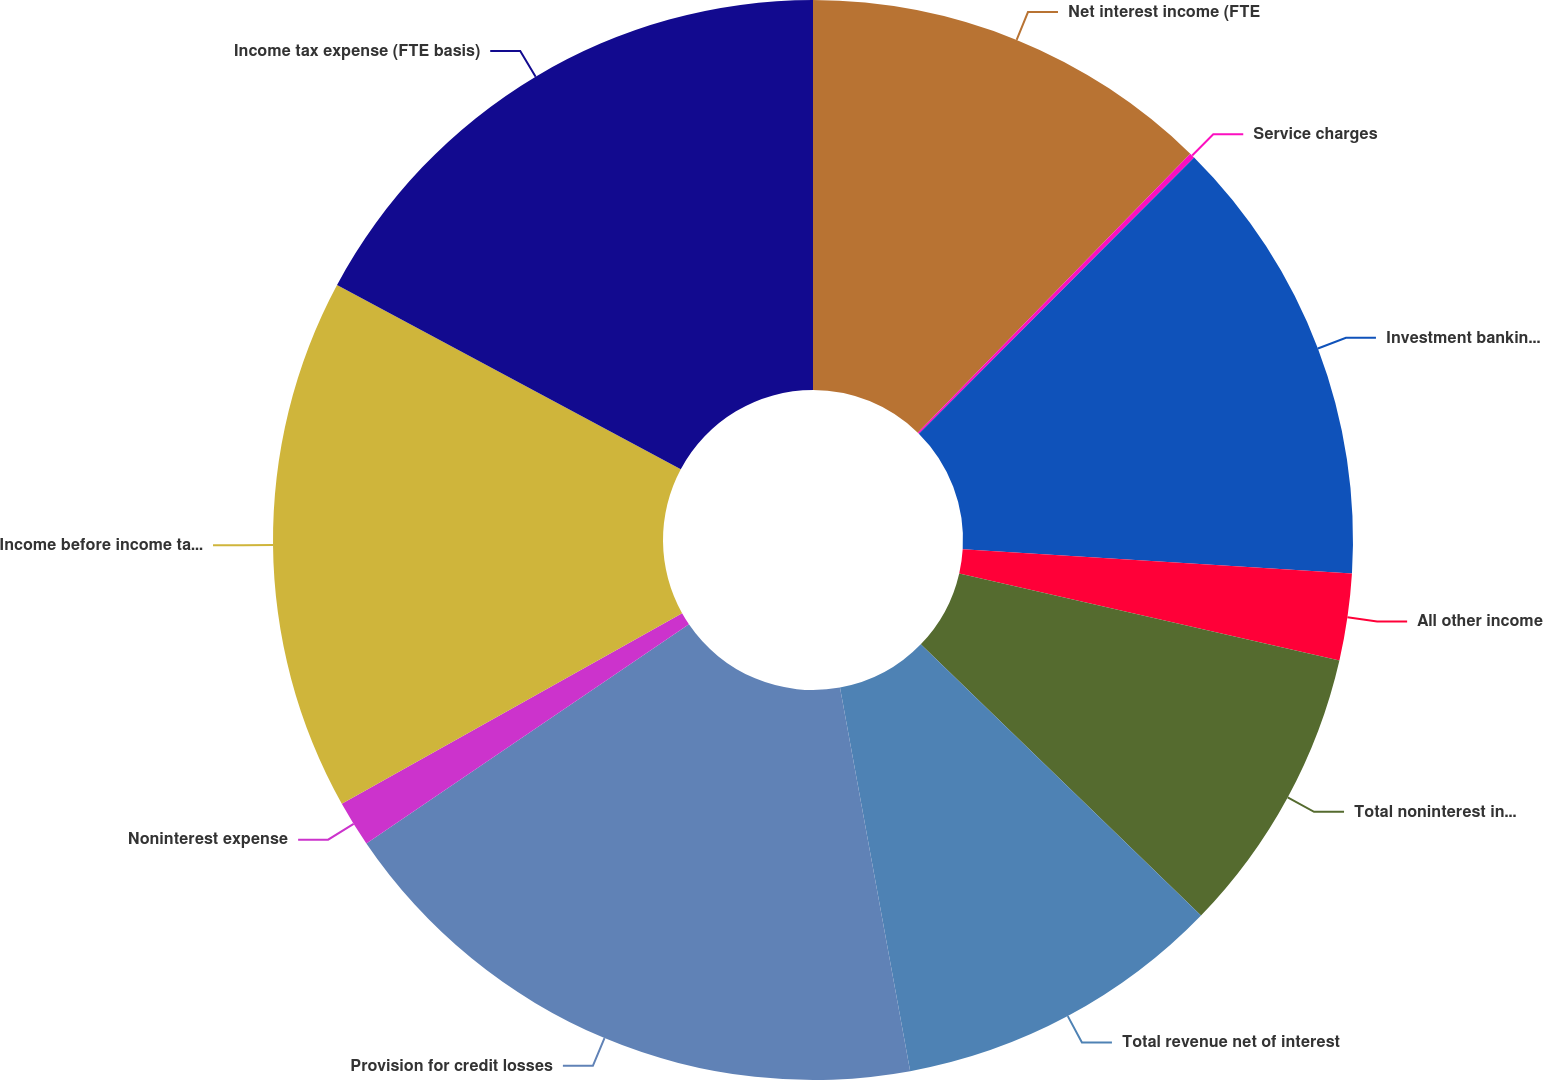Convert chart to OTSL. <chart><loc_0><loc_0><loc_500><loc_500><pie_chart><fcel>Net interest income (FTE<fcel>Service charges<fcel>Investment banking fees<fcel>All other income<fcel>Total noninterest income<fcel>Total revenue net of interest<fcel>Provision for credit losses<fcel>Noninterest expense<fcel>Income before income taxes<fcel>Income tax expense (FTE basis)<nl><fcel>12.31%<fcel>0.16%<fcel>13.52%<fcel>2.59%<fcel>8.66%<fcel>9.88%<fcel>18.38%<fcel>1.38%<fcel>15.95%<fcel>17.17%<nl></chart> 